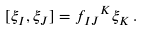<formula> <loc_0><loc_0><loc_500><loc_500>[ \xi _ { I } , \xi _ { J } ] = { f _ { I J } } ^ { K } \xi _ { K } \, .</formula> 